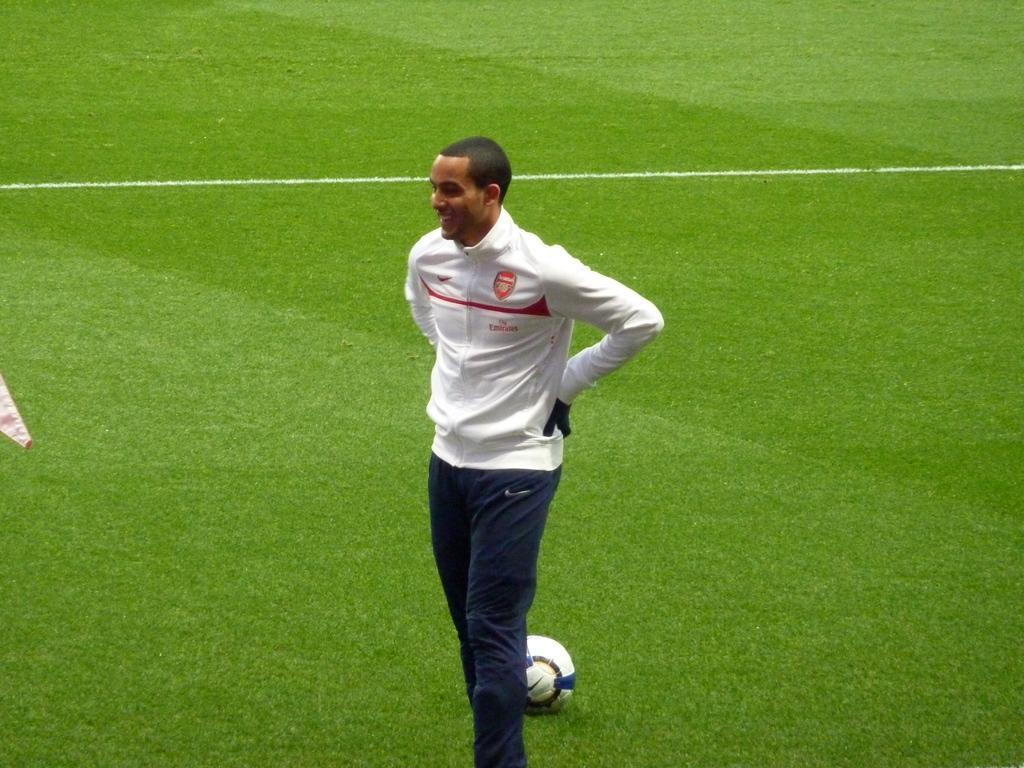How would you summarize this image in a sentence or two? In this picture there is a boy who is standing in the center of the image and there is a ball at the bottom side of the image, there is grassland on the floor. 